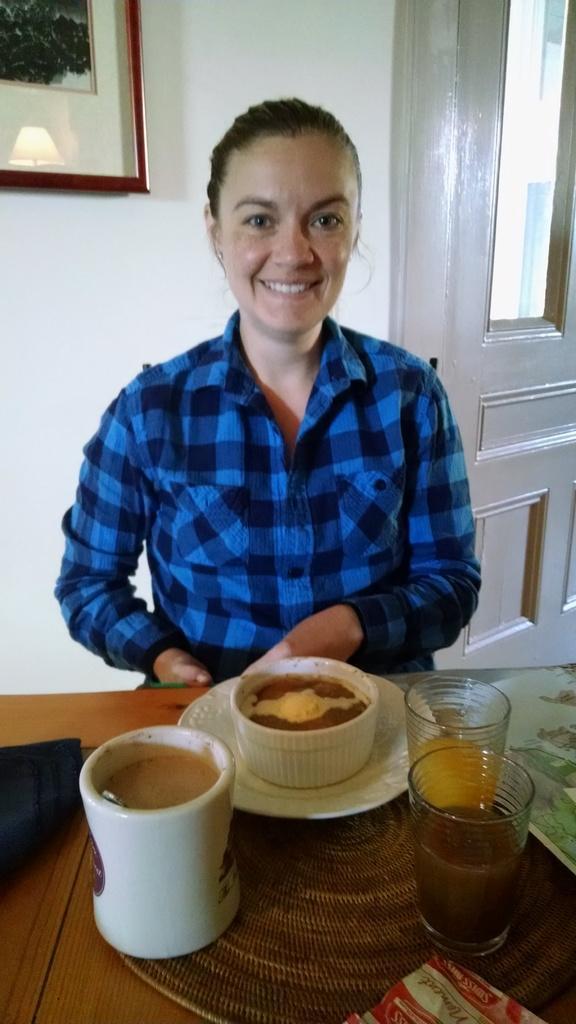In one or two sentences, can you explain what this image depicts? In this image I can see a woman is smiling. The woman is wearing blue color clothes. On the table I can see glasses, plate food items and other objects. In the background I can see a wall which has a photo attached to it. 